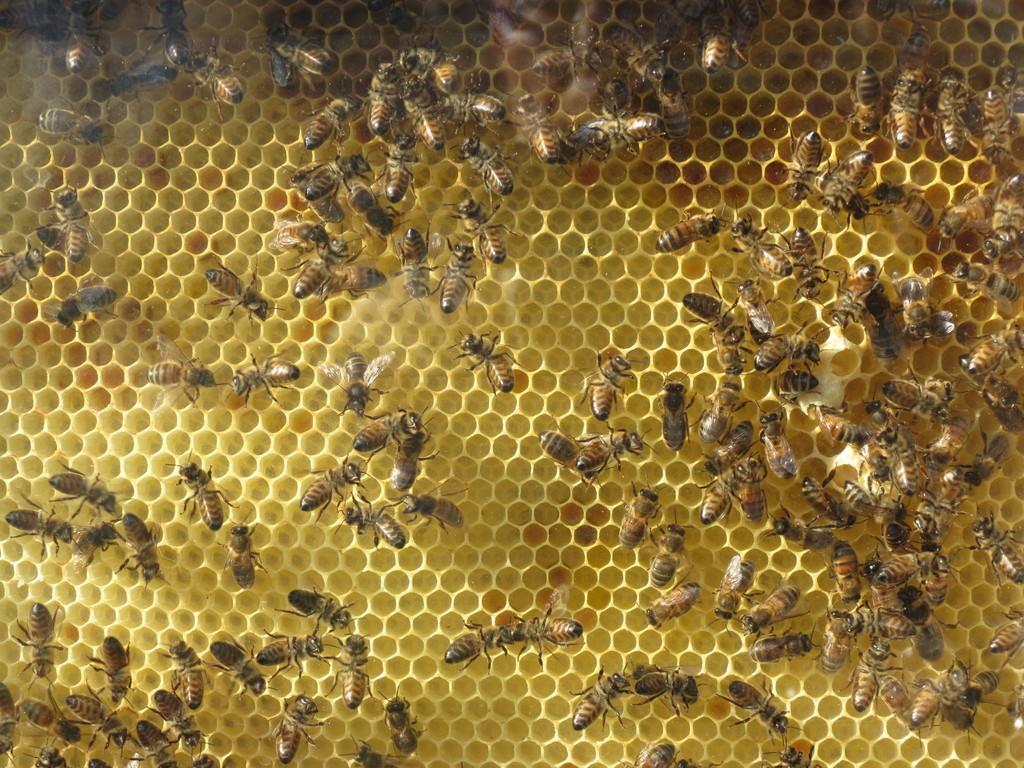Describe this image in one or two sentences. In this image we can see the insects on the beehive. 